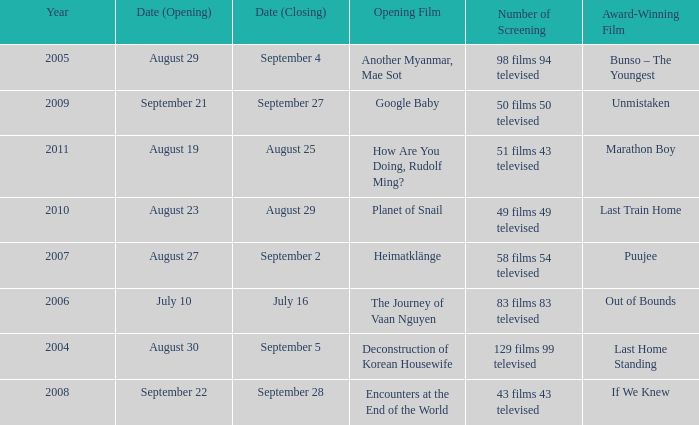How many award-winning films have the opening film of encounters at the end of the world? 1.0. 